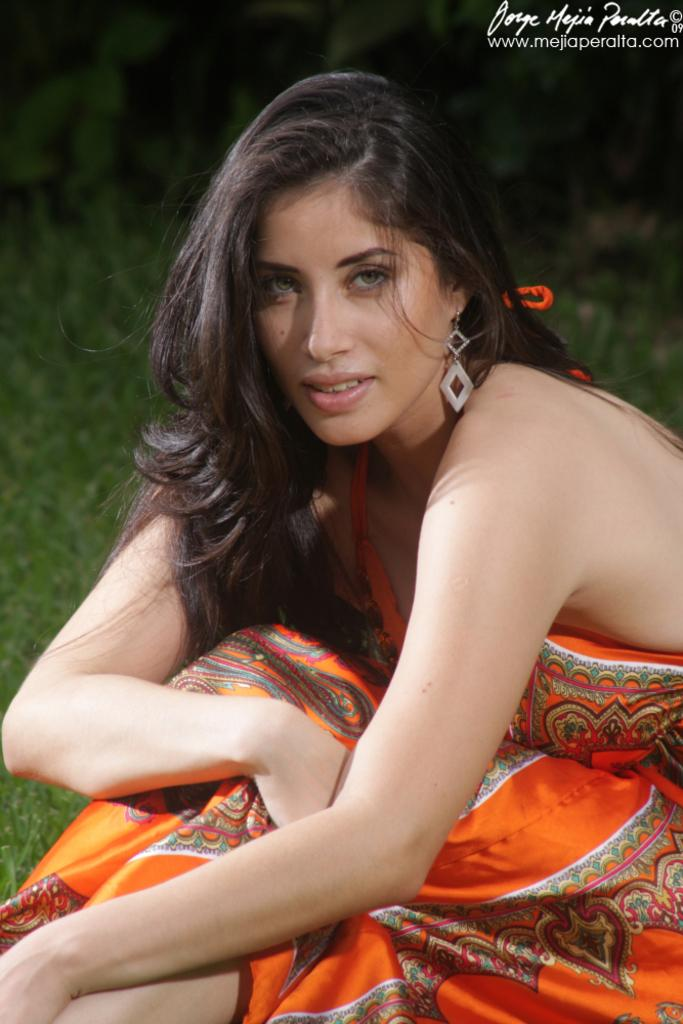Who is the main subject in the image? There is a lady in the image. What is the lady wearing? The lady is wearing an orange dress and an earring. What color is the background of the image? The background of the image is green. Is there any additional mark or feature in the image? Yes, there is a watermark in the right top corner of the image. What type of screw can be seen in the lady's hair in the image? There is no screw present in the lady's hair or in the image. How does the lady shake her head in the image? The lady is not shaking her head in the image; she is standing still. 